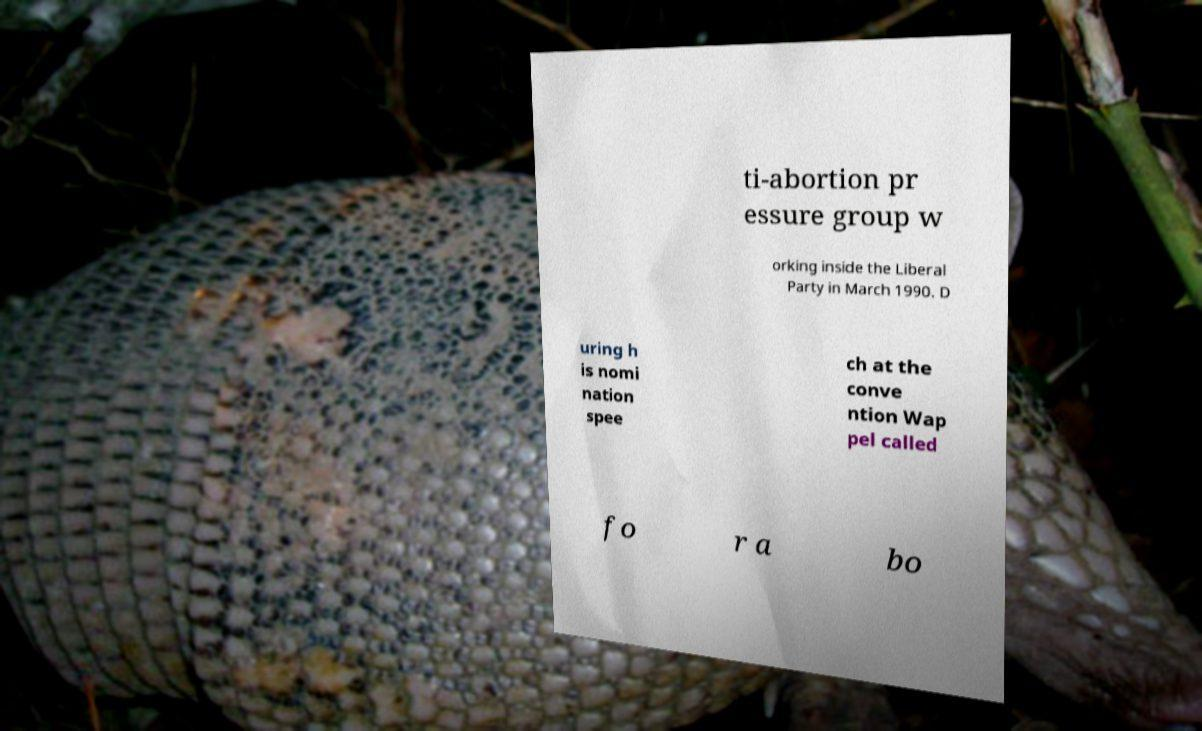For documentation purposes, I need the text within this image transcribed. Could you provide that? ti-abortion pr essure group w orking inside the Liberal Party in March 1990. D uring h is nomi nation spee ch at the conve ntion Wap pel called fo r a bo 